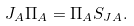<formula> <loc_0><loc_0><loc_500><loc_500>J _ { A } \Pi _ { A } = \Pi _ { A } S _ { J A } .</formula> 